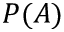<formula> <loc_0><loc_0><loc_500><loc_500>P ( A )</formula> 